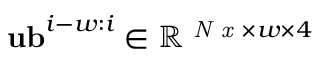<formula> <loc_0><loc_0><loc_500><loc_500>u b ^ { i - w \colon i } \in \mathbb { R } ^ { N x \times w \times 4 }</formula> 